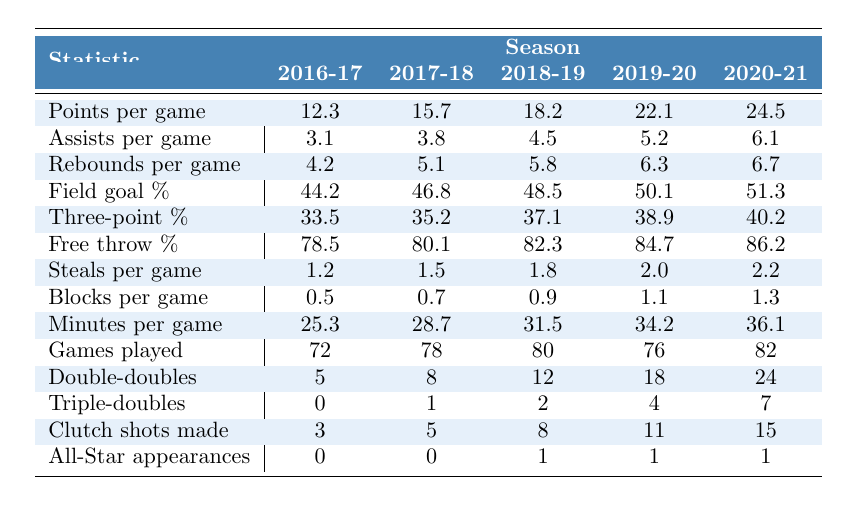What was the player's highest points per game in a season? The highest points per game can be identified in the "Points per game" row. The values are 12.3, 15.7, 18.2, 22.1, and 24.5, with 24.5 being the highest in the 2020-21 season.
Answer: 24.5 Which season had the best free throw percentage? The "Free throw %" values to examine are 78.5, 80.1, 82.3, 84.7, and 86.2. The highest among these values is 86.2, which occurred in the 2020-21 season.
Answer: 86.2 Did the player increase their assists per game every season? We will check the assists per game values: 3.1, 3.8, 4.5, 5.2, and 6.1. All values are increasing from one season to the next, confirming the consistent increase in assists.
Answer: Yes What is the average number of double-doubles over the five seasons? The double-doubles are 5, 8, 12, 18, and 24. We sum these up (5 + 8 + 12 + 18 + 24 = 67) and divide by 5 (67/5 = 13.4) to find the average.
Answer: 13.4 In which season did the player record the most triples-doubles? Looking at the "Triple-doubles" row, the values are 0, 1, 2, 4, and 7; the highest value of 7 occurred in the 2020-21 season.
Answer: 2020-21 How many games did the player play in the 2018-19 season? The "Games played" for the 2018-19 season is 80 as indicated in the row.
Answer: 80 What was the increase in rebounds per game from the 2017-18 season to the 2018-19 season? The rebounds per game for those seasons are 5.1 and 5.8 respectively. The increase is 5.8 - 5.1 = 0.7.
Answer: 0.7 Calculate the total number of clutch shots made across all seasons. The clutch shots made values are 3, 5, 8, 11, and 15. Adding these gives (3 + 5 + 8 + 11 + 15 = 42).
Answer: 42 Was the field goal percentage greater than 50% in any season? The field goal percentages are 44.2, 46.8, 48.5, 50.1, and 51.3. Since 50.1 and 51.3 are greater than 50%, it confirms that there were seasons with a percentage above that mark.
Answer: Yes What is the difference in steals per game from the 2020-21 season to the 2016-17 season? The steals per game are 2.2 (2020-21) and 1.2 (2016-17). The difference is 2.2 - 1.2 = 1.0.
Answer: 1.0 